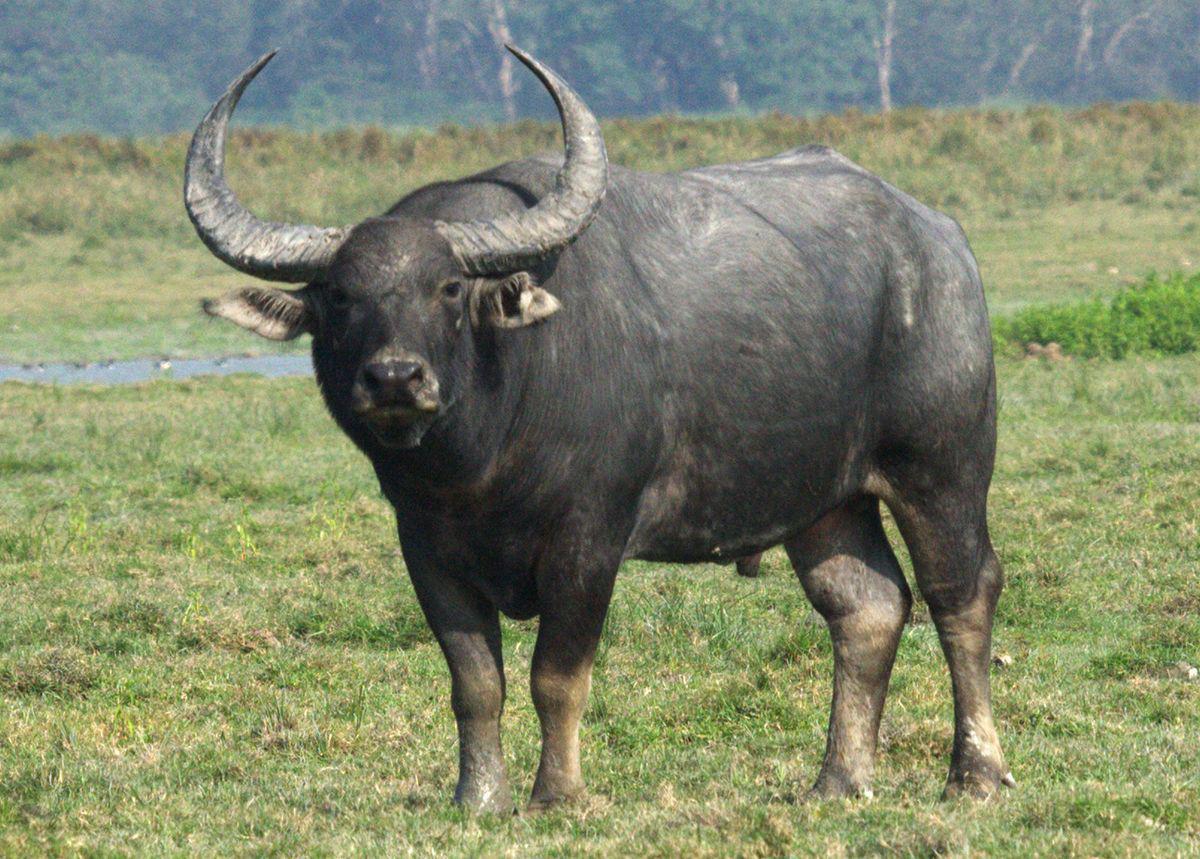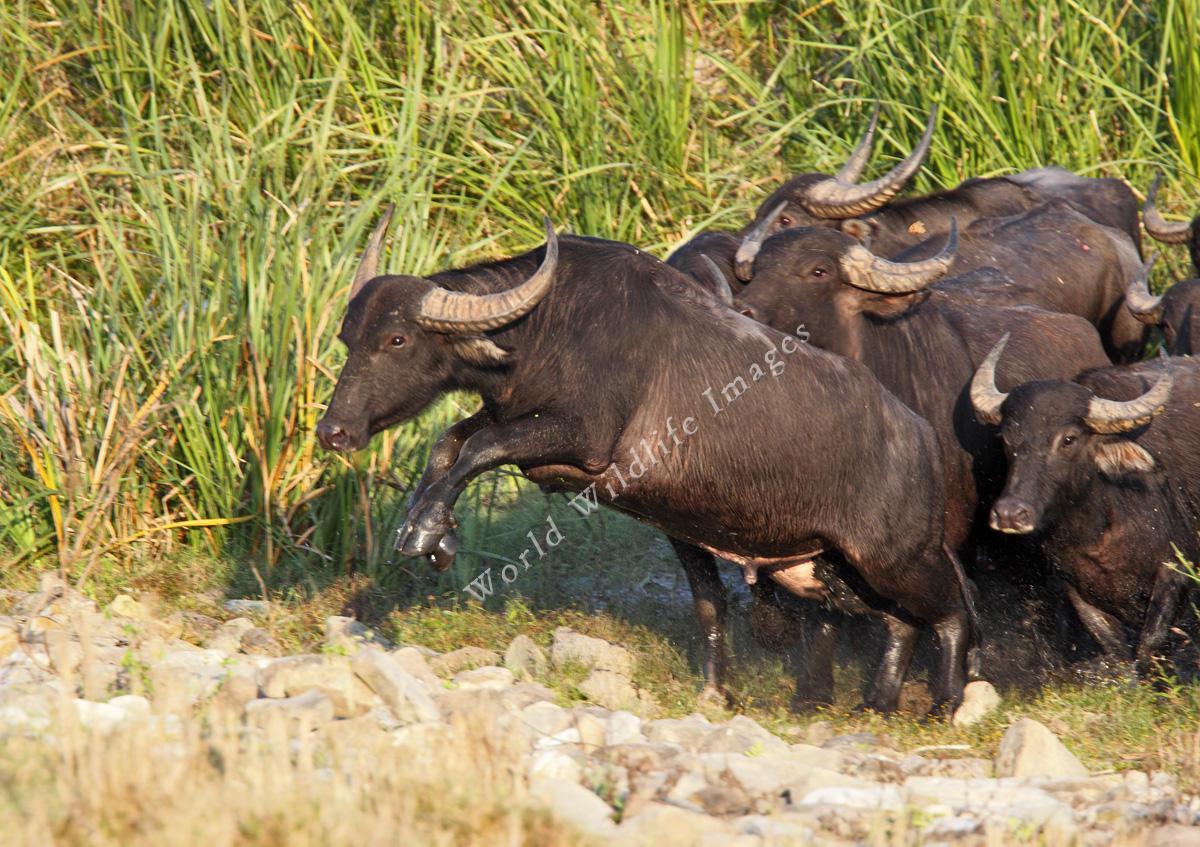The first image is the image on the left, the second image is the image on the right. Given the left and right images, does the statement "There are 3 animals in the images" hold true? Answer yes or no. No. 